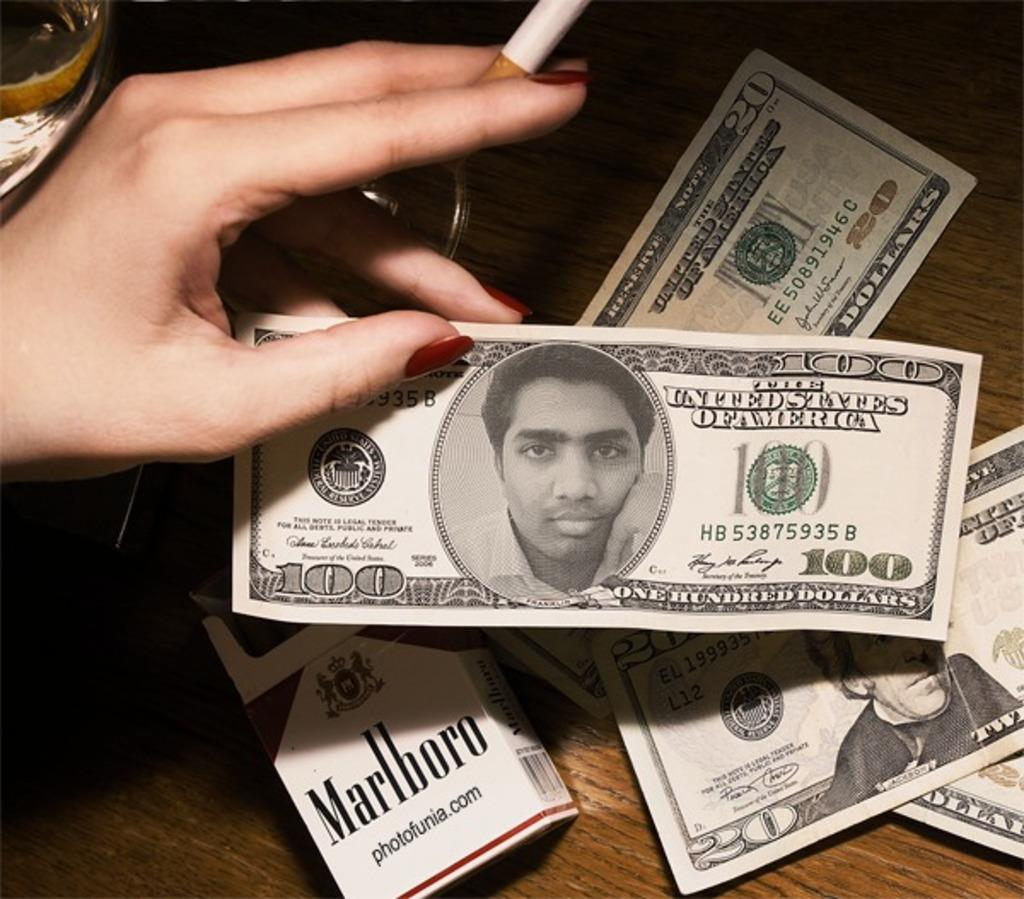<image>
Describe the image concisely. A fake one hundred dollar bill can be seen over a pack of Marlboro cigarettes. 